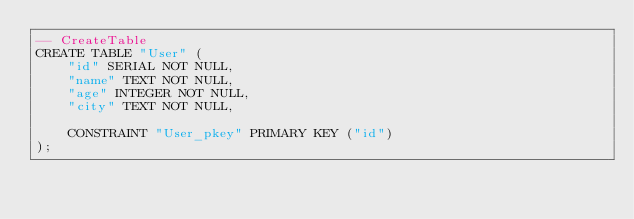<code> <loc_0><loc_0><loc_500><loc_500><_SQL_>-- CreateTable
CREATE TABLE "User" (
    "id" SERIAL NOT NULL,
    "name" TEXT NOT NULL,
    "age" INTEGER NOT NULL,
    "city" TEXT NOT NULL,

    CONSTRAINT "User_pkey" PRIMARY KEY ("id")
);
</code> 